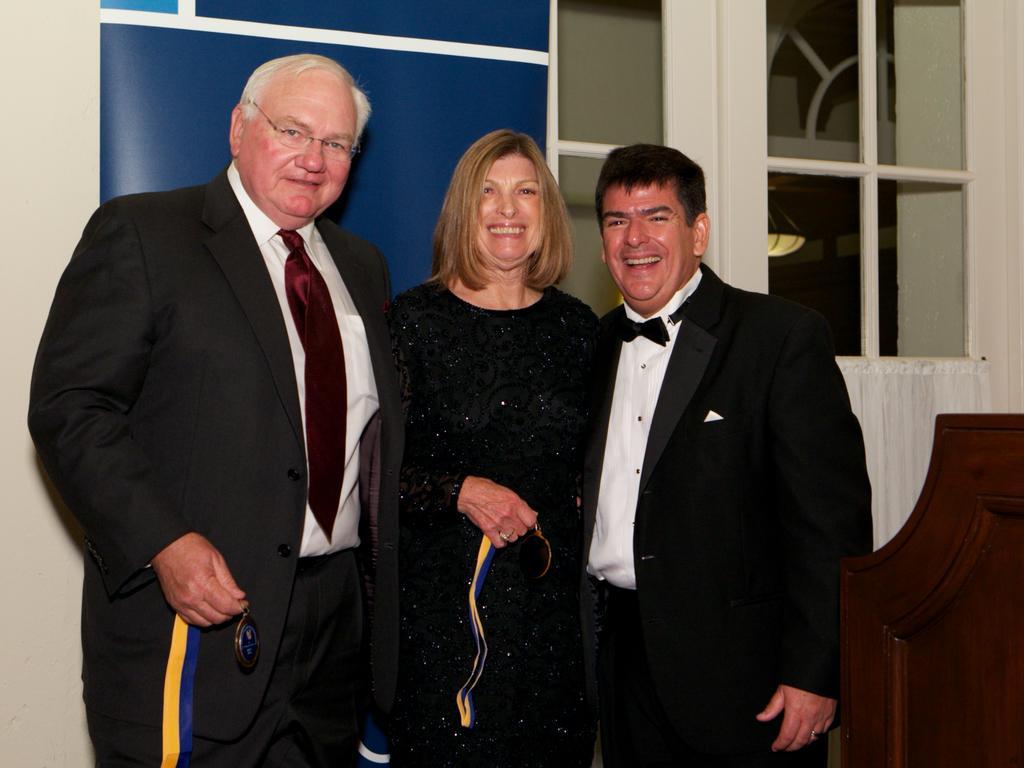Could you give a brief overview of what you see in this image? In the picture we can see two men and on woman standing together and smiling, men are in black color blazers, ties and shirts and woman is in black dress and behind them we can see wall which is blue in color and beside it we can see a window with white color frame and glass to it. 